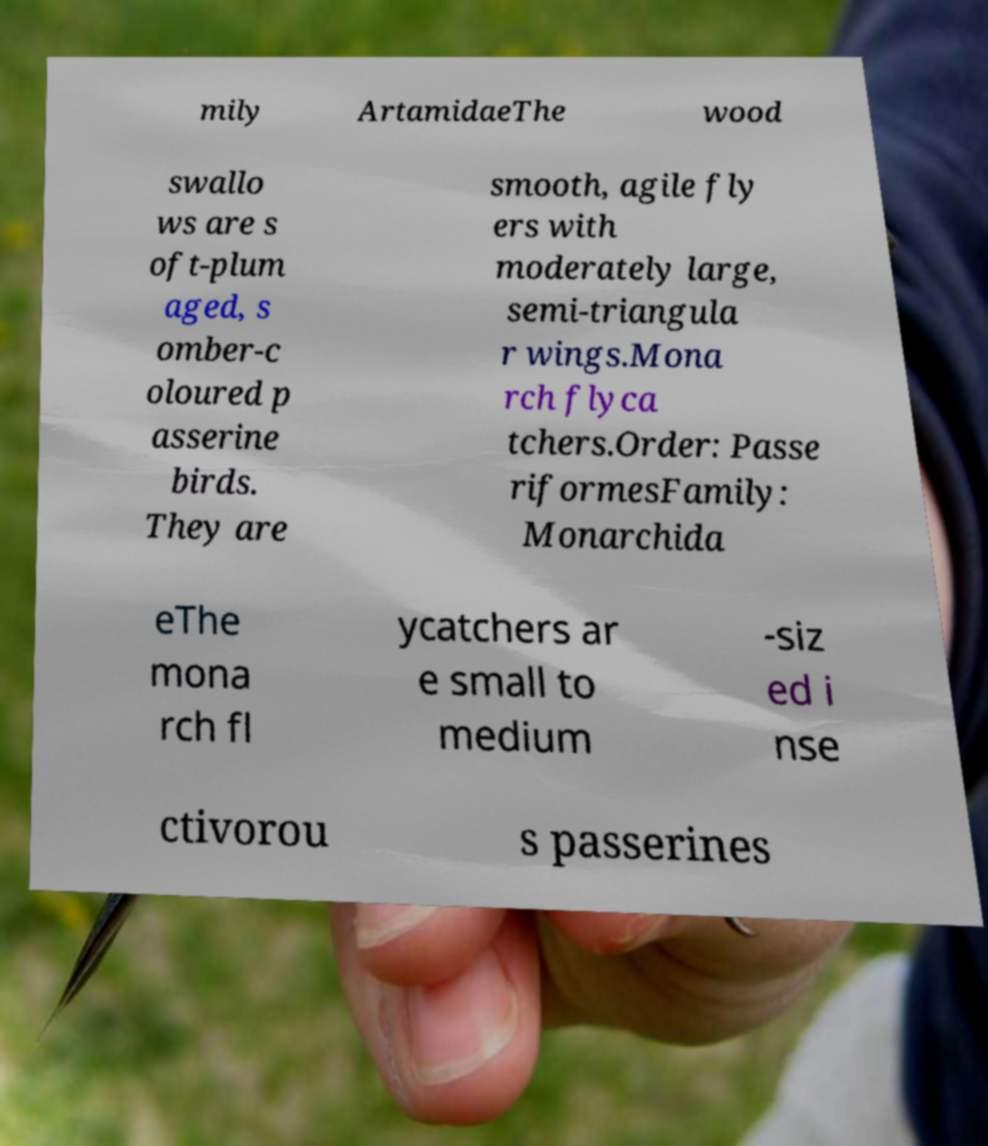There's text embedded in this image that I need extracted. Can you transcribe it verbatim? mily ArtamidaeThe wood swallo ws are s oft-plum aged, s omber-c oloured p asserine birds. They are smooth, agile fly ers with moderately large, semi-triangula r wings.Mona rch flyca tchers.Order: Passe riformesFamily: Monarchida eThe mona rch fl ycatchers ar e small to medium -siz ed i nse ctivorou s passerines 